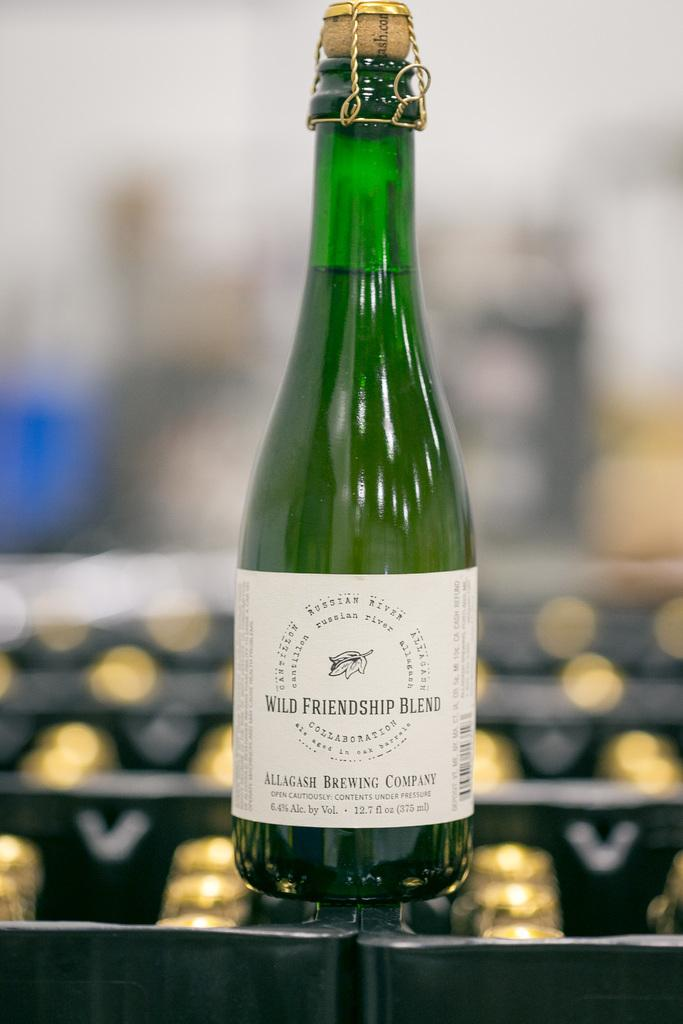What is the main subject of the image? The main subject of the image is a beverage. Where is the beverage located in the image? The beverage is placed on a table. How many legs does the beverage have in the image? Beverages do not have legs, so this question cannot be answered. 